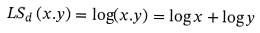<formula> <loc_0><loc_0><loc_500><loc_500>L S _ { d } \left ( x . y \right ) = \log ( x . y ) = \log x + \log y</formula> 